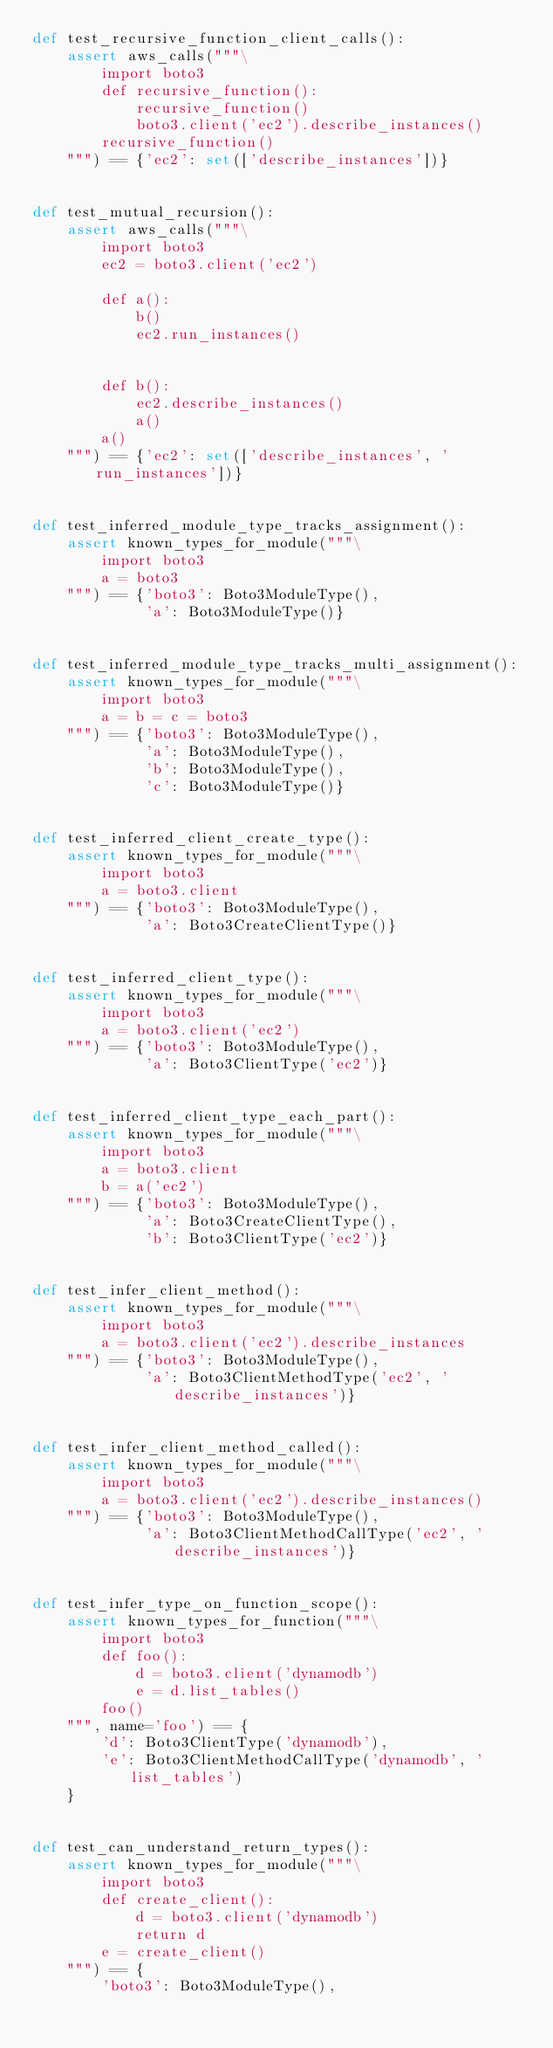<code> <loc_0><loc_0><loc_500><loc_500><_Python_>def test_recursive_function_client_calls():
    assert aws_calls("""\
        import boto3
        def recursive_function():
            recursive_function()
            boto3.client('ec2').describe_instances()
        recursive_function()
    """) == {'ec2': set(['describe_instances'])}


def test_mutual_recursion():
    assert aws_calls("""\
        import boto3
        ec2 = boto3.client('ec2')

        def a():
            b()
            ec2.run_instances()


        def b():
            ec2.describe_instances()
            a()
        a()
    """) == {'ec2': set(['describe_instances', 'run_instances'])}


def test_inferred_module_type_tracks_assignment():
    assert known_types_for_module("""\
        import boto3
        a = boto3
    """) == {'boto3': Boto3ModuleType(),
             'a': Boto3ModuleType()}


def test_inferred_module_type_tracks_multi_assignment():
    assert known_types_for_module("""\
        import boto3
        a = b = c = boto3
    """) == {'boto3': Boto3ModuleType(),
             'a': Boto3ModuleType(),
             'b': Boto3ModuleType(),
             'c': Boto3ModuleType()}


def test_inferred_client_create_type():
    assert known_types_for_module("""\
        import boto3
        a = boto3.client
    """) == {'boto3': Boto3ModuleType(),
             'a': Boto3CreateClientType()}


def test_inferred_client_type():
    assert known_types_for_module("""\
        import boto3
        a = boto3.client('ec2')
    """) == {'boto3': Boto3ModuleType(),
             'a': Boto3ClientType('ec2')}


def test_inferred_client_type_each_part():
    assert known_types_for_module("""\
        import boto3
        a = boto3.client
        b = a('ec2')
    """) == {'boto3': Boto3ModuleType(),
             'a': Boto3CreateClientType(),
             'b': Boto3ClientType('ec2')}


def test_infer_client_method():
    assert known_types_for_module("""\
        import boto3
        a = boto3.client('ec2').describe_instances
    """) == {'boto3': Boto3ModuleType(),
             'a': Boto3ClientMethodType('ec2', 'describe_instances')}


def test_infer_client_method_called():
    assert known_types_for_module("""\
        import boto3
        a = boto3.client('ec2').describe_instances()
    """) == {'boto3': Boto3ModuleType(),
             'a': Boto3ClientMethodCallType('ec2', 'describe_instances')}


def test_infer_type_on_function_scope():
    assert known_types_for_function("""\
        import boto3
        def foo():
            d = boto3.client('dynamodb')
            e = d.list_tables()
        foo()
    """, name='foo') == {
        'd': Boto3ClientType('dynamodb'),
        'e': Boto3ClientMethodCallType('dynamodb', 'list_tables')
    }


def test_can_understand_return_types():
    assert known_types_for_module("""\
        import boto3
        def create_client():
            d = boto3.client('dynamodb')
            return d
        e = create_client()
    """) == {
        'boto3': Boto3ModuleType(),</code> 